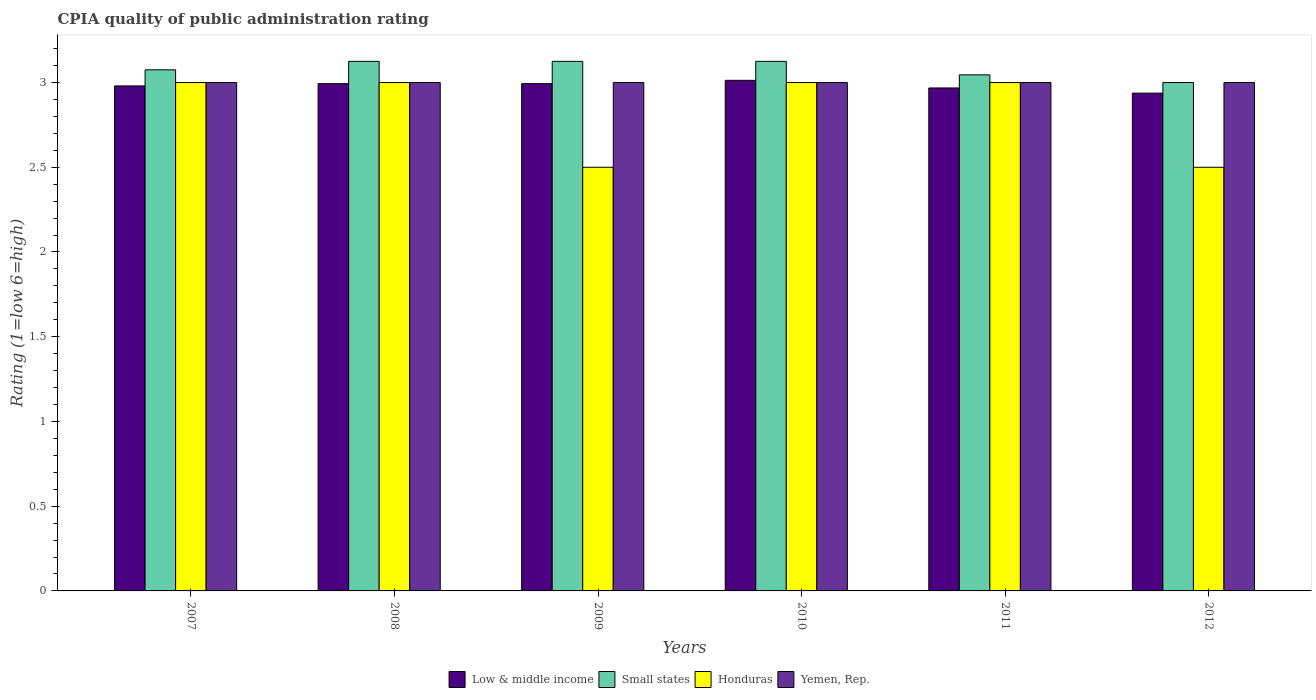How many groups of bars are there?
Your answer should be compact. 6. How many bars are there on the 5th tick from the left?
Keep it short and to the point. 4. Across all years, what is the minimum CPIA rating in Honduras?
Your answer should be very brief. 2.5. In which year was the CPIA rating in Yemen, Rep. maximum?
Keep it short and to the point. 2007. In which year was the CPIA rating in Low & middle income minimum?
Provide a succinct answer. 2012. What is the total CPIA rating in Small states in the graph?
Keep it short and to the point. 18.5. What is the difference between the CPIA rating in Small states in 2008 and the CPIA rating in Yemen, Rep. in 2009?
Keep it short and to the point. 0.12. What is the average CPIA rating in Honduras per year?
Offer a very short reply. 2.83. In the year 2011, what is the difference between the CPIA rating in Honduras and CPIA rating in Low & middle income?
Give a very brief answer. 0.03. Is the difference between the CPIA rating in Honduras in 2007 and 2010 greater than the difference between the CPIA rating in Low & middle income in 2007 and 2010?
Keep it short and to the point. Yes. In how many years, is the CPIA rating in Honduras greater than the average CPIA rating in Honduras taken over all years?
Make the answer very short. 4. What does the 4th bar from the right in 2012 represents?
Ensure brevity in your answer.  Low & middle income. Is it the case that in every year, the sum of the CPIA rating in Yemen, Rep. and CPIA rating in Honduras is greater than the CPIA rating in Small states?
Provide a short and direct response. Yes. How many bars are there?
Provide a short and direct response. 24. Are all the bars in the graph horizontal?
Make the answer very short. No. How many years are there in the graph?
Keep it short and to the point. 6. Does the graph contain any zero values?
Provide a succinct answer. No. Where does the legend appear in the graph?
Your answer should be very brief. Bottom center. What is the title of the graph?
Your answer should be very brief. CPIA quality of public administration rating. What is the label or title of the X-axis?
Make the answer very short. Years. What is the Rating (1=low 6=high) in Low & middle income in 2007?
Provide a short and direct response. 2.98. What is the Rating (1=low 6=high) of Small states in 2007?
Ensure brevity in your answer.  3.08. What is the Rating (1=low 6=high) in Yemen, Rep. in 2007?
Your response must be concise. 3. What is the Rating (1=low 6=high) of Low & middle income in 2008?
Offer a terse response. 2.99. What is the Rating (1=low 6=high) in Small states in 2008?
Offer a terse response. 3.12. What is the Rating (1=low 6=high) of Low & middle income in 2009?
Keep it short and to the point. 2.99. What is the Rating (1=low 6=high) of Small states in 2009?
Make the answer very short. 3.12. What is the Rating (1=low 6=high) of Honduras in 2009?
Your response must be concise. 2.5. What is the Rating (1=low 6=high) in Low & middle income in 2010?
Give a very brief answer. 3.01. What is the Rating (1=low 6=high) of Small states in 2010?
Give a very brief answer. 3.12. What is the Rating (1=low 6=high) of Honduras in 2010?
Offer a very short reply. 3. What is the Rating (1=low 6=high) in Low & middle income in 2011?
Make the answer very short. 2.97. What is the Rating (1=low 6=high) in Small states in 2011?
Provide a succinct answer. 3.05. What is the Rating (1=low 6=high) of Honduras in 2011?
Your response must be concise. 3. What is the Rating (1=low 6=high) of Low & middle income in 2012?
Your answer should be very brief. 2.94. What is the Rating (1=low 6=high) of Yemen, Rep. in 2012?
Provide a succinct answer. 3. Across all years, what is the maximum Rating (1=low 6=high) of Low & middle income?
Give a very brief answer. 3.01. Across all years, what is the maximum Rating (1=low 6=high) in Small states?
Your answer should be compact. 3.12. Across all years, what is the minimum Rating (1=low 6=high) of Low & middle income?
Offer a very short reply. 2.94. Across all years, what is the minimum Rating (1=low 6=high) in Small states?
Offer a terse response. 3. What is the total Rating (1=low 6=high) in Low & middle income in the graph?
Offer a very short reply. 17.89. What is the total Rating (1=low 6=high) of Small states in the graph?
Make the answer very short. 18.5. What is the total Rating (1=low 6=high) in Honduras in the graph?
Ensure brevity in your answer.  17. What is the difference between the Rating (1=low 6=high) of Low & middle income in 2007 and that in 2008?
Your answer should be very brief. -0.01. What is the difference between the Rating (1=low 6=high) of Small states in 2007 and that in 2008?
Provide a succinct answer. -0.05. What is the difference between the Rating (1=low 6=high) in Yemen, Rep. in 2007 and that in 2008?
Your answer should be very brief. 0. What is the difference between the Rating (1=low 6=high) in Low & middle income in 2007 and that in 2009?
Offer a very short reply. -0.01. What is the difference between the Rating (1=low 6=high) of Low & middle income in 2007 and that in 2010?
Your answer should be compact. -0.03. What is the difference between the Rating (1=low 6=high) in Yemen, Rep. in 2007 and that in 2010?
Offer a very short reply. 0. What is the difference between the Rating (1=low 6=high) in Low & middle income in 2007 and that in 2011?
Provide a short and direct response. 0.01. What is the difference between the Rating (1=low 6=high) of Small states in 2007 and that in 2011?
Offer a very short reply. 0.03. What is the difference between the Rating (1=low 6=high) in Honduras in 2007 and that in 2011?
Your response must be concise. 0. What is the difference between the Rating (1=low 6=high) in Low & middle income in 2007 and that in 2012?
Provide a succinct answer. 0.04. What is the difference between the Rating (1=low 6=high) of Small states in 2007 and that in 2012?
Your answer should be very brief. 0.07. What is the difference between the Rating (1=low 6=high) in Yemen, Rep. in 2007 and that in 2012?
Provide a succinct answer. 0. What is the difference between the Rating (1=low 6=high) in Low & middle income in 2008 and that in 2009?
Make the answer very short. -0. What is the difference between the Rating (1=low 6=high) of Small states in 2008 and that in 2009?
Offer a terse response. 0. What is the difference between the Rating (1=low 6=high) in Honduras in 2008 and that in 2009?
Give a very brief answer. 0.5. What is the difference between the Rating (1=low 6=high) of Low & middle income in 2008 and that in 2010?
Provide a short and direct response. -0.02. What is the difference between the Rating (1=low 6=high) of Honduras in 2008 and that in 2010?
Make the answer very short. 0. What is the difference between the Rating (1=low 6=high) of Low & middle income in 2008 and that in 2011?
Keep it short and to the point. 0.03. What is the difference between the Rating (1=low 6=high) of Small states in 2008 and that in 2011?
Offer a terse response. 0.08. What is the difference between the Rating (1=low 6=high) of Honduras in 2008 and that in 2011?
Offer a very short reply. 0. What is the difference between the Rating (1=low 6=high) in Low & middle income in 2008 and that in 2012?
Your answer should be very brief. 0.06. What is the difference between the Rating (1=low 6=high) in Honduras in 2008 and that in 2012?
Keep it short and to the point. 0.5. What is the difference between the Rating (1=low 6=high) in Yemen, Rep. in 2008 and that in 2012?
Provide a succinct answer. 0. What is the difference between the Rating (1=low 6=high) of Low & middle income in 2009 and that in 2010?
Keep it short and to the point. -0.02. What is the difference between the Rating (1=low 6=high) of Small states in 2009 and that in 2010?
Provide a short and direct response. 0. What is the difference between the Rating (1=low 6=high) of Low & middle income in 2009 and that in 2011?
Ensure brevity in your answer.  0.03. What is the difference between the Rating (1=low 6=high) of Small states in 2009 and that in 2011?
Offer a terse response. 0.08. What is the difference between the Rating (1=low 6=high) in Yemen, Rep. in 2009 and that in 2011?
Offer a very short reply. 0. What is the difference between the Rating (1=low 6=high) of Low & middle income in 2009 and that in 2012?
Your answer should be compact. 0.06. What is the difference between the Rating (1=low 6=high) in Honduras in 2009 and that in 2012?
Ensure brevity in your answer.  0. What is the difference between the Rating (1=low 6=high) of Low & middle income in 2010 and that in 2011?
Provide a succinct answer. 0.04. What is the difference between the Rating (1=low 6=high) in Small states in 2010 and that in 2011?
Your response must be concise. 0.08. What is the difference between the Rating (1=low 6=high) of Honduras in 2010 and that in 2011?
Offer a very short reply. 0. What is the difference between the Rating (1=low 6=high) of Low & middle income in 2010 and that in 2012?
Give a very brief answer. 0.08. What is the difference between the Rating (1=low 6=high) in Honduras in 2010 and that in 2012?
Your response must be concise. 0.5. What is the difference between the Rating (1=low 6=high) of Low & middle income in 2011 and that in 2012?
Your answer should be very brief. 0.03. What is the difference between the Rating (1=low 6=high) in Small states in 2011 and that in 2012?
Provide a succinct answer. 0.05. What is the difference between the Rating (1=low 6=high) of Low & middle income in 2007 and the Rating (1=low 6=high) of Small states in 2008?
Your response must be concise. -0.14. What is the difference between the Rating (1=low 6=high) in Low & middle income in 2007 and the Rating (1=low 6=high) in Honduras in 2008?
Provide a succinct answer. -0.02. What is the difference between the Rating (1=low 6=high) of Low & middle income in 2007 and the Rating (1=low 6=high) of Yemen, Rep. in 2008?
Ensure brevity in your answer.  -0.02. What is the difference between the Rating (1=low 6=high) in Small states in 2007 and the Rating (1=low 6=high) in Honduras in 2008?
Give a very brief answer. 0.07. What is the difference between the Rating (1=low 6=high) of Small states in 2007 and the Rating (1=low 6=high) of Yemen, Rep. in 2008?
Provide a short and direct response. 0.07. What is the difference between the Rating (1=low 6=high) in Honduras in 2007 and the Rating (1=low 6=high) in Yemen, Rep. in 2008?
Offer a terse response. 0. What is the difference between the Rating (1=low 6=high) of Low & middle income in 2007 and the Rating (1=low 6=high) of Small states in 2009?
Your response must be concise. -0.14. What is the difference between the Rating (1=low 6=high) in Low & middle income in 2007 and the Rating (1=low 6=high) in Honduras in 2009?
Ensure brevity in your answer.  0.48. What is the difference between the Rating (1=low 6=high) of Low & middle income in 2007 and the Rating (1=low 6=high) of Yemen, Rep. in 2009?
Your answer should be very brief. -0.02. What is the difference between the Rating (1=low 6=high) of Small states in 2007 and the Rating (1=low 6=high) of Honduras in 2009?
Ensure brevity in your answer.  0.57. What is the difference between the Rating (1=low 6=high) of Small states in 2007 and the Rating (1=low 6=high) of Yemen, Rep. in 2009?
Keep it short and to the point. 0.07. What is the difference between the Rating (1=low 6=high) of Low & middle income in 2007 and the Rating (1=low 6=high) of Small states in 2010?
Provide a succinct answer. -0.14. What is the difference between the Rating (1=low 6=high) of Low & middle income in 2007 and the Rating (1=low 6=high) of Honduras in 2010?
Offer a terse response. -0.02. What is the difference between the Rating (1=low 6=high) in Low & middle income in 2007 and the Rating (1=low 6=high) in Yemen, Rep. in 2010?
Give a very brief answer. -0.02. What is the difference between the Rating (1=low 6=high) in Small states in 2007 and the Rating (1=low 6=high) in Honduras in 2010?
Ensure brevity in your answer.  0.07. What is the difference between the Rating (1=low 6=high) of Small states in 2007 and the Rating (1=low 6=high) of Yemen, Rep. in 2010?
Make the answer very short. 0.07. What is the difference between the Rating (1=low 6=high) of Honduras in 2007 and the Rating (1=low 6=high) of Yemen, Rep. in 2010?
Offer a very short reply. 0. What is the difference between the Rating (1=low 6=high) in Low & middle income in 2007 and the Rating (1=low 6=high) in Small states in 2011?
Provide a succinct answer. -0.07. What is the difference between the Rating (1=low 6=high) of Low & middle income in 2007 and the Rating (1=low 6=high) of Honduras in 2011?
Your answer should be very brief. -0.02. What is the difference between the Rating (1=low 6=high) of Low & middle income in 2007 and the Rating (1=low 6=high) of Yemen, Rep. in 2011?
Your answer should be compact. -0.02. What is the difference between the Rating (1=low 6=high) in Small states in 2007 and the Rating (1=low 6=high) in Honduras in 2011?
Your answer should be compact. 0.07. What is the difference between the Rating (1=low 6=high) in Small states in 2007 and the Rating (1=low 6=high) in Yemen, Rep. in 2011?
Offer a terse response. 0.07. What is the difference between the Rating (1=low 6=high) in Low & middle income in 2007 and the Rating (1=low 6=high) in Small states in 2012?
Make the answer very short. -0.02. What is the difference between the Rating (1=low 6=high) of Low & middle income in 2007 and the Rating (1=low 6=high) of Honduras in 2012?
Provide a succinct answer. 0.48. What is the difference between the Rating (1=low 6=high) of Low & middle income in 2007 and the Rating (1=low 6=high) of Yemen, Rep. in 2012?
Make the answer very short. -0.02. What is the difference between the Rating (1=low 6=high) of Small states in 2007 and the Rating (1=low 6=high) of Honduras in 2012?
Give a very brief answer. 0.57. What is the difference between the Rating (1=low 6=high) in Small states in 2007 and the Rating (1=low 6=high) in Yemen, Rep. in 2012?
Make the answer very short. 0.07. What is the difference between the Rating (1=low 6=high) in Low & middle income in 2008 and the Rating (1=low 6=high) in Small states in 2009?
Keep it short and to the point. -0.13. What is the difference between the Rating (1=low 6=high) of Low & middle income in 2008 and the Rating (1=low 6=high) of Honduras in 2009?
Your answer should be very brief. 0.49. What is the difference between the Rating (1=low 6=high) of Low & middle income in 2008 and the Rating (1=low 6=high) of Yemen, Rep. in 2009?
Make the answer very short. -0.01. What is the difference between the Rating (1=low 6=high) of Small states in 2008 and the Rating (1=low 6=high) of Yemen, Rep. in 2009?
Your response must be concise. 0.12. What is the difference between the Rating (1=low 6=high) of Low & middle income in 2008 and the Rating (1=low 6=high) of Small states in 2010?
Your answer should be very brief. -0.13. What is the difference between the Rating (1=low 6=high) of Low & middle income in 2008 and the Rating (1=low 6=high) of Honduras in 2010?
Keep it short and to the point. -0.01. What is the difference between the Rating (1=low 6=high) in Low & middle income in 2008 and the Rating (1=low 6=high) in Yemen, Rep. in 2010?
Offer a terse response. -0.01. What is the difference between the Rating (1=low 6=high) in Small states in 2008 and the Rating (1=low 6=high) in Honduras in 2010?
Offer a terse response. 0.12. What is the difference between the Rating (1=low 6=high) of Small states in 2008 and the Rating (1=low 6=high) of Yemen, Rep. in 2010?
Provide a short and direct response. 0.12. What is the difference between the Rating (1=low 6=high) in Honduras in 2008 and the Rating (1=low 6=high) in Yemen, Rep. in 2010?
Give a very brief answer. 0. What is the difference between the Rating (1=low 6=high) in Low & middle income in 2008 and the Rating (1=low 6=high) in Small states in 2011?
Provide a short and direct response. -0.05. What is the difference between the Rating (1=low 6=high) of Low & middle income in 2008 and the Rating (1=low 6=high) of Honduras in 2011?
Make the answer very short. -0.01. What is the difference between the Rating (1=low 6=high) in Low & middle income in 2008 and the Rating (1=low 6=high) in Yemen, Rep. in 2011?
Ensure brevity in your answer.  -0.01. What is the difference between the Rating (1=low 6=high) of Small states in 2008 and the Rating (1=low 6=high) of Yemen, Rep. in 2011?
Offer a very short reply. 0.12. What is the difference between the Rating (1=low 6=high) in Low & middle income in 2008 and the Rating (1=low 6=high) in Small states in 2012?
Make the answer very short. -0.01. What is the difference between the Rating (1=low 6=high) of Low & middle income in 2008 and the Rating (1=low 6=high) of Honduras in 2012?
Offer a very short reply. 0.49. What is the difference between the Rating (1=low 6=high) in Low & middle income in 2008 and the Rating (1=low 6=high) in Yemen, Rep. in 2012?
Ensure brevity in your answer.  -0.01. What is the difference between the Rating (1=low 6=high) of Small states in 2008 and the Rating (1=low 6=high) of Honduras in 2012?
Offer a very short reply. 0.62. What is the difference between the Rating (1=low 6=high) in Low & middle income in 2009 and the Rating (1=low 6=high) in Small states in 2010?
Your answer should be very brief. -0.13. What is the difference between the Rating (1=low 6=high) of Low & middle income in 2009 and the Rating (1=low 6=high) of Honduras in 2010?
Give a very brief answer. -0.01. What is the difference between the Rating (1=low 6=high) of Low & middle income in 2009 and the Rating (1=low 6=high) of Yemen, Rep. in 2010?
Keep it short and to the point. -0.01. What is the difference between the Rating (1=low 6=high) in Small states in 2009 and the Rating (1=low 6=high) in Yemen, Rep. in 2010?
Your response must be concise. 0.12. What is the difference between the Rating (1=low 6=high) in Low & middle income in 2009 and the Rating (1=low 6=high) in Small states in 2011?
Your answer should be compact. -0.05. What is the difference between the Rating (1=low 6=high) in Low & middle income in 2009 and the Rating (1=low 6=high) in Honduras in 2011?
Provide a short and direct response. -0.01. What is the difference between the Rating (1=low 6=high) of Low & middle income in 2009 and the Rating (1=low 6=high) of Yemen, Rep. in 2011?
Give a very brief answer. -0.01. What is the difference between the Rating (1=low 6=high) in Small states in 2009 and the Rating (1=low 6=high) in Yemen, Rep. in 2011?
Your answer should be compact. 0.12. What is the difference between the Rating (1=low 6=high) of Low & middle income in 2009 and the Rating (1=low 6=high) of Small states in 2012?
Offer a very short reply. -0.01. What is the difference between the Rating (1=low 6=high) in Low & middle income in 2009 and the Rating (1=low 6=high) in Honduras in 2012?
Provide a succinct answer. 0.49. What is the difference between the Rating (1=low 6=high) of Low & middle income in 2009 and the Rating (1=low 6=high) of Yemen, Rep. in 2012?
Offer a very short reply. -0.01. What is the difference between the Rating (1=low 6=high) in Small states in 2009 and the Rating (1=low 6=high) in Yemen, Rep. in 2012?
Give a very brief answer. 0.12. What is the difference between the Rating (1=low 6=high) in Honduras in 2009 and the Rating (1=low 6=high) in Yemen, Rep. in 2012?
Your answer should be very brief. -0.5. What is the difference between the Rating (1=low 6=high) in Low & middle income in 2010 and the Rating (1=low 6=high) in Small states in 2011?
Provide a succinct answer. -0.03. What is the difference between the Rating (1=low 6=high) of Low & middle income in 2010 and the Rating (1=low 6=high) of Honduras in 2011?
Make the answer very short. 0.01. What is the difference between the Rating (1=low 6=high) in Low & middle income in 2010 and the Rating (1=low 6=high) in Yemen, Rep. in 2011?
Provide a short and direct response. 0.01. What is the difference between the Rating (1=low 6=high) in Honduras in 2010 and the Rating (1=low 6=high) in Yemen, Rep. in 2011?
Make the answer very short. 0. What is the difference between the Rating (1=low 6=high) in Low & middle income in 2010 and the Rating (1=low 6=high) in Small states in 2012?
Make the answer very short. 0.01. What is the difference between the Rating (1=low 6=high) of Low & middle income in 2010 and the Rating (1=low 6=high) of Honduras in 2012?
Ensure brevity in your answer.  0.51. What is the difference between the Rating (1=low 6=high) of Low & middle income in 2010 and the Rating (1=low 6=high) of Yemen, Rep. in 2012?
Provide a succinct answer. 0.01. What is the difference between the Rating (1=low 6=high) of Small states in 2010 and the Rating (1=low 6=high) of Honduras in 2012?
Provide a succinct answer. 0.62. What is the difference between the Rating (1=low 6=high) of Small states in 2010 and the Rating (1=low 6=high) of Yemen, Rep. in 2012?
Give a very brief answer. 0.12. What is the difference between the Rating (1=low 6=high) in Low & middle income in 2011 and the Rating (1=low 6=high) in Small states in 2012?
Your response must be concise. -0.03. What is the difference between the Rating (1=low 6=high) in Low & middle income in 2011 and the Rating (1=low 6=high) in Honduras in 2012?
Your answer should be compact. 0.47. What is the difference between the Rating (1=low 6=high) in Low & middle income in 2011 and the Rating (1=low 6=high) in Yemen, Rep. in 2012?
Provide a short and direct response. -0.03. What is the difference between the Rating (1=low 6=high) in Small states in 2011 and the Rating (1=low 6=high) in Honduras in 2012?
Offer a terse response. 0.55. What is the difference between the Rating (1=low 6=high) of Small states in 2011 and the Rating (1=low 6=high) of Yemen, Rep. in 2012?
Make the answer very short. 0.05. What is the difference between the Rating (1=low 6=high) in Honduras in 2011 and the Rating (1=low 6=high) in Yemen, Rep. in 2012?
Keep it short and to the point. 0. What is the average Rating (1=low 6=high) in Low & middle income per year?
Provide a succinct answer. 2.98. What is the average Rating (1=low 6=high) of Small states per year?
Your response must be concise. 3.08. What is the average Rating (1=low 6=high) in Honduras per year?
Give a very brief answer. 2.83. What is the average Rating (1=low 6=high) in Yemen, Rep. per year?
Provide a succinct answer. 3. In the year 2007, what is the difference between the Rating (1=low 6=high) of Low & middle income and Rating (1=low 6=high) of Small states?
Offer a very short reply. -0.1. In the year 2007, what is the difference between the Rating (1=low 6=high) in Low & middle income and Rating (1=low 6=high) in Honduras?
Your response must be concise. -0.02. In the year 2007, what is the difference between the Rating (1=low 6=high) of Low & middle income and Rating (1=low 6=high) of Yemen, Rep.?
Offer a terse response. -0.02. In the year 2007, what is the difference between the Rating (1=low 6=high) in Small states and Rating (1=low 6=high) in Honduras?
Your answer should be very brief. 0.07. In the year 2007, what is the difference between the Rating (1=low 6=high) in Small states and Rating (1=low 6=high) in Yemen, Rep.?
Your answer should be very brief. 0.07. In the year 2007, what is the difference between the Rating (1=low 6=high) of Honduras and Rating (1=low 6=high) of Yemen, Rep.?
Your answer should be very brief. 0. In the year 2008, what is the difference between the Rating (1=low 6=high) of Low & middle income and Rating (1=low 6=high) of Small states?
Make the answer very short. -0.13. In the year 2008, what is the difference between the Rating (1=low 6=high) in Low & middle income and Rating (1=low 6=high) in Honduras?
Provide a succinct answer. -0.01. In the year 2008, what is the difference between the Rating (1=low 6=high) of Low & middle income and Rating (1=low 6=high) of Yemen, Rep.?
Provide a succinct answer. -0.01. In the year 2008, what is the difference between the Rating (1=low 6=high) of Small states and Rating (1=low 6=high) of Honduras?
Your response must be concise. 0.12. In the year 2008, what is the difference between the Rating (1=low 6=high) of Honduras and Rating (1=low 6=high) of Yemen, Rep.?
Offer a terse response. 0. In the year 2009, what is the difference between the Rating (1=low 6=high) of Low & middle income and Rating (1=low 6=high) of Small states?
Your answer should be compact. -0.13. In the year 2009, what is the difference between the Rating (1=low 6=high) of Low & middle income and Rating (1=low 6=high) of Honduras?
Offer a terse response. 0.49. In the year 2009, what is the difference between the Rating (1=low 6=high) in Low & middle income and Rating (1=low 6=high) in Yemen, Rep.?
Your answer should be compact. -0.01. In the year 2009, what is the difference between the Rating (1=low 6=high) of Small states and Rating (1=low 6=high) of Yemen, Rep.?
Provide a succinct answer. 0.12. In the year 2010, what is the difference between the Rating (1=low 6=high) in Low & middle income and Rating (1=low 6=high) in Small states?
Make the answer very short. -0.11. In the year 2010, what is the difference between the Rating (1=low 6=high) in Low & middle income and Rating (1=low 6=high) in Honduras?
Provide a succinct answer. 0.01. In the year 2010, what is the difference between the Rating (1=low 6=high) of Low & middle income and Rating (1=low 6=high) of Yemen, Rep.?
Provide a short and direct response. 0.01. In the year 2010, what is the difference between the Rating (1=low 6=high) of Small states and Rating (1=low 6=high) of Honduras?
Your response must be concise. 0.12. In the year 2010, what is the difference between the Rating (1=low 6=high) in Small states and Rating (1=low 6=high) in Yemen, Rep.?
Offer a very short reply. 0.12. In the year 2010, what is the difference between the Rating (1=low 6=high) of Honduras and Rating (1=low 6=high) of Yemen, Rep.?
Your response must be concise. 0. In the year 2011, what is the difference between the Rating (1=low 6=high) of Low & middle income and Rating (1=low 6=high) of Small states?
Your answer should be very brief. -0.08. In the year 2011, what is the difference between the Rating (1=low 6=high) of Low & middle income and Rating (1=low 6=high) of Honduras?
Provide a succinct answer. -0.03. In the year 2011, what is the difference between the Rating (1=low 6=high) of Low & middle income and Rating (1=low 6=high) of Yemen, Rep.?
Give a very brief answer. -0.03. In the year 2011, what is the difference between the Rating (1=low 6=high) of Small states and Rating (1=low 6=high) of Honduras?
Provide a short and direct response. 0.05. In the year 2011, what is the difference between the Rating (1=low 6=high) in Small states and Rating (1=low 6=high) in Yemen, Rep.?
Offer a very short reply. 0.05. In the year 2012, what is the difference between the Rating (1=low 6=high) of Low & middle income and Rating (1=low 6=high) of Small states?
Make the answer very short. -0.06. In the year 2012, what is the difference between the Rating (1=low 6=high) of Low & middle income and Rating (1=low 6=high) of Honduras?
Your answer should be compact. 0.44. In the year 2012, what is the difference between the Rating (1=low 6=high) in Low & middle income and Rating (1=low 6=high) in Yemen, Rep.?
Ensure brevity in your answer.  -0.06. In the year 2012, what is the difference between the Rating (1=low 6=high) in Small states and Rating (1=low 6=high) in Honduras?
Provide a short and direct response. 0.5. What is the ratio of the Rating (1=low 6=high) in Small states in 2007 to that in 2008?
Offer a terse response. 0.98. What is the ratio of the Rating (1=low 6=high) in Honduras in 2007 to that in 2008?
Ensure brevity in your answer.  1. What is the ratio of the Rating (1=low 6=high) in Yemen, Rep. in 2007 to that in 2008?
Keep it short and to the point. 1. What is the ratio of the Rating (1=low 6=high) of Honduras in 2007 to that in 2009?
Give a very brief answer. 1.2. What is the ratio of the Rating (1=low 6=high) of Yemen, Rep. in 2007 to that in 2009?
Your answer should be very brief. 1. What is the ratio of the Rating (1=low 6=high) in Yemen, Rep. in 2007 to that in 2010?
Provide a short and direct response. 1. What is the ratio of the Rating (1=low 6=high) of Small states in 2007 to that in 2011?
Make the answer very short. 1.01. What is the ratio of the Rating (1=low 6=high) of Yemen, Rep. in 2007 to that in 2011?
Give a very brief answer. 1. What is the ratio of the Rating (1=low 6=high) in Low & middle income in 2007 to that in 2012?
Your answer should be compact. 1.01. What is the ratio of the Rating (1=low 6=high) in Yemen, Rep. in 2007 to that in 2012?
Offer a very short reply. 1. What is the ratio of the Rating (1=low 6=high) of Honduras in 2008 to that in 2009?
Ensure brevity in your answer.  1.2. What is the ratio of the Rating (1=low 6=high) in Low & middle income in 2008 to that in 2010?
Provide a succinct answer. 0.99. What is the ratio of the Rating (1=low 6=high) in Honduras in 2008 to that in 2010?
Make the answer very short. 1. What is the ratio of the Rating (1=low 6=high) of Yemen, Rep. in 2008 to that in 2010?
Provide a succinct answer. 1. What is the ratio of the Rating (1=low 6=high) of Low & middle income in 2008 to that in 2011?
Provide a short and direct response. 1.01. What is the ratio of the Rating (1=low 6=high) in Small states in 2008 to that in 2011?
Provide a succinct answer. 1.03. What is the ratio of the Rating (1=low 6=high) of Yemen, Rep. in 2008 to that in 2011?
Keep it short and to the point. 1. What is the ratio of the Rating (1=low 6=high) in Small states in 2008 to that in 2012?
Ensure brevity in your answer.  1.04. What is the ratio of the Rating (1=low 6=high) of Yemen, Rep. in 2008 to that in 2012?
Offer a terse response. 1. What is the ratio of the Rating (1=low 6=high) of Small states in 2009 to that in 2010?
Provide a succinct answer. 1. What is the ratio of the Rating (1=low 6=high) in Honduras in 2009 to that in 2010?
Give a very brief answer. 0.83. What is the ratio of the Rating (1=low 6=high) in Yemen, Rep. in 2009 to that in 2010?
Your answer should be very brief. 1. What is the ratio of the Rating (1=low 6=high) in Low & middle income in 2009 to that in 2011?
Your answer should be compact. 1.01. What is the ratio of the Rating (1=low 6=high) of Small states in 2009 to that in 2011?
Give a very brief answer. 1.03. What is the ratio of the Rating (1=low 6=high) in Honduras in 2009 to that in 2011?
Ensure brevity in your answer.  0.83. What is the ratio of the Rating (1=low 6=high) of Low & middle income in 2009 to that in 2012?
Keep it short and to the point. 1.02. What is the ratio of the Rating (1=low 6=high) of Small states in 2009 to that in 2012?
Ensure brevity in your answer.  1.04. What is the ratio of the Rating (1=low 6=high) of Low & middle income in 2010 to that in 2011?
Your answer should be very brief. 1.02. What is the ratio of the Rating (1=low 6=high) in Small states in 2010 to that in 2011?
Provide a short and direct response. 1.03. What is the ratio of the Rating (1=low 6=high) in Yemen, Rep. in 2010 to that in 2011?
Offer a terse response. 1. What is the ratio of the Rating (1=low 6=high) of Low & middle income in 2010 to that in 2012?
Your answer should be very brief. 1.03. What is the ratio of the Rating (1=low 6=high) in Small states in 2010 to that in 2012?
Offer a very short reply. 1.04. What is the ratio of the Rating (1=low 6=high) in Low & middle income in 2011 to that in 2012?
Your answer should be compact. 1.01. What is the ratio of the Rating (1=low 6=high) of Small states in 2011 to that in 2012?
Make the answer very short. 1.02. What is the difference between the highest and the second highest Rating (1=low 6=high) in Low & middle income?
Provide a short and direct response. 0.02. What is the difference between the highest and the second highest Rating (1=low 6=high) of Small states?
Provide a short and direct response. 0. What is the difference between the highest and the second highest Rating (1=low 6=high) in Yemen, Rep.?
Give a very brief answer. 0. What is the difference between the highest and the lowest Rating (1=low 6=high) in Low & middle income?
Offer a very short reply. 0.08. What is the difference between the highest and the lowest Rating (1=low 6=high) of Small states?
Your response must be concise. 0.12. 